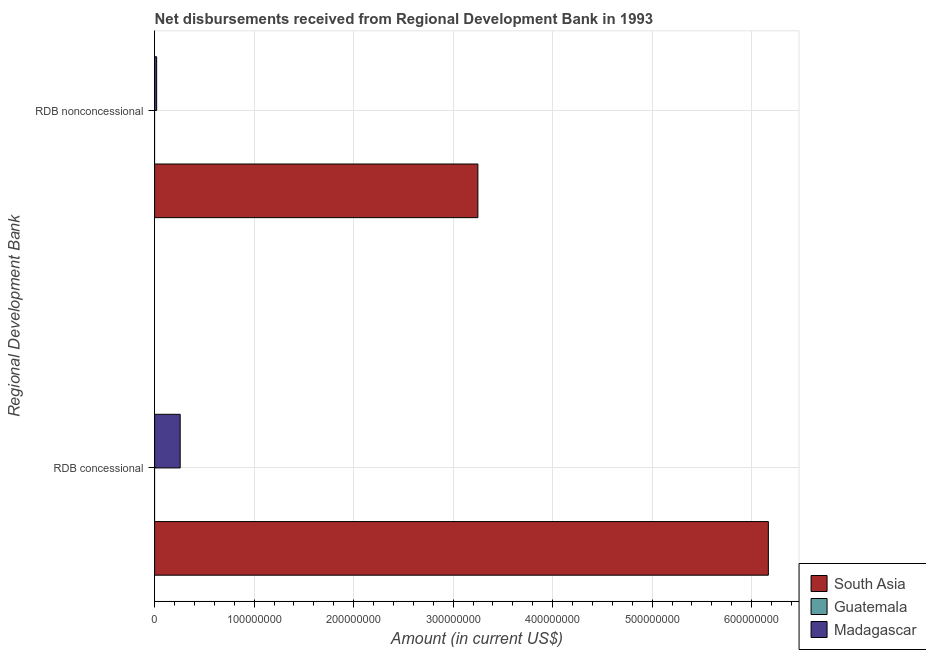How many different coloured bars are there?
Make the answer very short. 2. How many groups of bars are there?
Keep it short and to the point. 2. Are the number of bars per tick equal to the number of legend labels?
Your answer should be compact. No. Are the number of bars on each tick of the Y-axis equal?
Keep it short and to the point. Yes. How many bars are there on the 1st tick from the top?
Your answer should be very brief. 2. How many bars are there on the 1st tick from the bottom?
Your answer should be very brief. 2. What is the label of the 2nd group of bars from the top?
Give a very brief answer. RDB concessional. What is the net concessional disbursements from rdb in Madagascar?
Your answer should be compact. 2.57e+07. Across all countries, what is the maximum net non concessional disbursements from rdb?
Give a very brief answer. 3.25e+08. Across all countries, what is the minimum net non concessional disbursements from rdb?
Make the answer very short. 0. What is the total net concessional disbursements from rdb in the graph?
Ensure brevity in your answer.  6.42e+08. What is the difference between the net concessional disbursements from rdb in Madagascar and that in South Asia?
Keep it short and to the point. -5.91e+08. What is the difference between the net non concessional disbursements from rdb in Madagascar and the net concessional disbursements from rdb in South Asia?
Give a very brief answer. -6.15e+08. What is the average net concessional disbursements from rdb per country?
Your response must be concise. 2.14e+08. What is the difference between the net concessional disbursements from rdb and net non concessional disbursements from rdb in Madagascar?
Your answer should be very brief. 2.36e+07. What is the ratio of the net concessional disbursements from rdb in Madagascar to that in South Asia?
Keep it short and to the point. 0.04. Is the net concessional disbursements from rdb in Madagascar less than that in South Asia?
Ensure brevity in your answer.  Yes. Are all the bars in the graph horizontal?
Make the answer very short. Yes. How many countries are there in the graph?
Provide a short and direct response. 3. What is the difference between two consecutive major ticks on the X-axis?
Give a very brief answer. 1.00e+08. Where does the legend appear in the graph?
Make the answer very short. Bottom right. How many legend labels are there?
Provide a succinct answer. 3. How are the legend labels stacked?
Offer a very short reply. Vertical. What is the title of the graph?
Provide a short and direct response. Net disbursements received from Regional Development Bank in 1993. Does "Cuba" appear as one of the legend labels in the graph?
Provide a succinct answer. No. What is the label or title of the Y-axis?
Offer a very short reply. Regional Development Bank. What is the Amount (in current US$) of South Asia in RDB concessional?
Make the answer very short. 6.17e+08. What is the Amount (in current US$) in Guatemala in RDB concessional?
Give a very brief answer. 0. What is the Amount (in current US$) in Madagascar in RDB concessional?
Offer a very short reply. 2.57e+07. What is the Amount (in current US$) of South Asia in RDB nonconcessional?
Keep it short and to the point. 3.25e+08. What is the Amount (in current US$) in Madagascar in RDB nonconcessional?
Provide a short and direct response. 2.06e+06. Across all Regional Development Bank, what is the maximum Amount (in current US$) of South Asia?
Make the answer very short. 6.17e+08. Across all Regional Development Bank, what is the maximum Amount (in current US$) of Madagascar?
Ensure brevity in your answer.  2.57e+07. Across all Regional Development Bank, what is the minimum Amount (in current US$) of South Asia?
Provide a succinct answer. 3.25e+08. Across all Regional Development Bank, what is the minimum Amount (in current US$) of Madagascar?
Your answer should be compact. 2.06e+06. What is the total Amount (in current US$) of South Asia in the graph?
Provide a succinct answer. 9.42e+08. What is the total Amount (in current US$) in Madagascar in the graph?
Offer a very short reply. 2.78e+07. What is the difference between the Amount (in current US$) in South Asia in RDB concessional and that in RDB nonconcessional?
Ensure brevity in your answer.  2.92e+08. What is the difference between the Amount (in current US$) in Madagascar in RDB concessional and that in RDB nonconcessional?
Ensure brevity in your answer.  2.36e+07. What is the difference between the Amount (in current US$) in South Asia in RDB concessional and the Amount (in current US$) in Madagascar in RDB nonconcessional?
Provide a succinct answer. 6.15e+08. What is the average Amount (in current US$) of South Asia per Regional Development Bank?
Provide a short and direct response. 4.71e+08. What is the average Amount (in current US$) in Madagascar per Regional Development Bank?
Ensure brevity in your answer.  1.39e+07. What is the difference between the Amount (in current US$) of South Asia and Amount (in current US$) of Madagascar in RDB concessional?
Ensure brevity in your answer.  5.91e+08. What is the difference between the Amount (in current US$) in South Asia and Amount (in current US$) in Madagascar in RDB nonconcessional?
Offer a very short reply. 3.23e+08. What is the ratio of the Amount (in current US$) in South Asia in RDB concessional to that in RDB nonconcessional?
Keep it short and to the point. 1.9. What is the ratio of the Amount (in current US$) in Madagascar in RDB concessional to that in RDB nonconcessional?
Offer a very short reply. 12.47. What is the difference between the highest and the second highest Amount (in current US$) of South Asia?
Make the answer very short. 2.92e+08. What is the difference between the highest and the second highest Amount (in current US$) in Madagascar?
Your answer should be compact. 2.36e+07. What is the difference between the highest and the lowest Amount (in current US$) of South Asia?
Ensure brevity in your answer.  2.92e+08. What is the difference between the highest and the lowest Amount (in current US$) in Madagascar?
Offer a very short reply. 2.36e+07. 